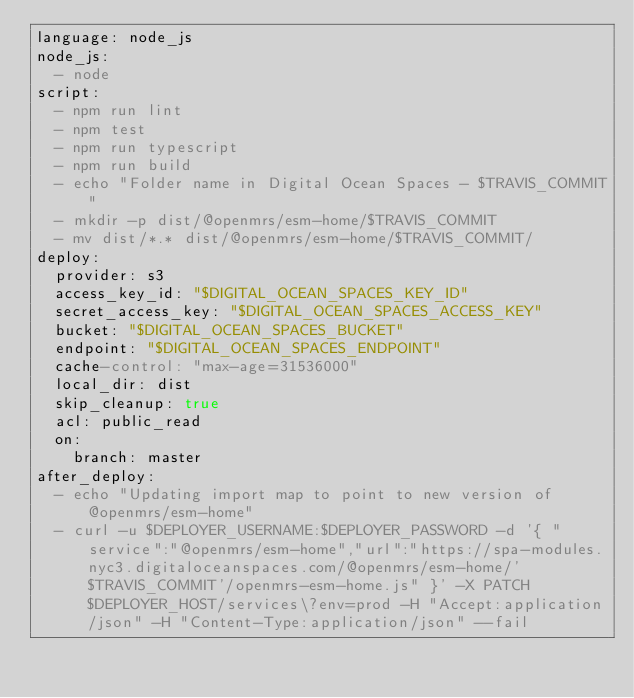<code> <loc_0><loc_0><loc_500><loc_500><_YAML_>language: node_js
node_js:
  - node
script:
  - npm run lint
  - npm test
  - npm run typescript
  - npm run build
  - echo "Folder name in Digital Ocean Spaces - $TRAVIS_COMMIT"
  - mkdir -p dist/@openmrs/esm-home/$TRAVIS_COMMIT
  - mv dist/*.* dist/@openmrs/esm-home/$TRAVIS_COMMIT/
deploy:
  provider: s3
  access_key_id: "$DIGITAL_OCEAN_SPACES_KEY_ID"
  secret_access_key: "$DIGITAL_OCEAN_SPACES_ACCESS_KEY"
  bucket: "$DIGITAL_OCEAN_SPACES_BUCKET"
  endpoint: "$DIGITAL_OCEAN_SPACES_ENDPOINT"
  cache-control: "max-age=31536000"
  local_dir: dist
  skip_cleanup: true
  acl: public_read
  on:
    branch: master
after_deploy:
  - echo "Updating import map to point to new version of @openmrs/esm-home"
  - curl -u $DEPLOYER_USERNAME:$DEPLOYER_PASSWORD -d '{ "service":"@openmrs/esm-home","url":"https://spa-modules.nyc3.digitaloceanspaces.com/@openmrs/esm-home/'$TRAVIS_COMMIT'/openmrs-esm-home.js" }' -X PATCH $DEPLOYER_HOST/services\?env=prod -H "Accept:application/json" -H "Content-Type:application/json" --fail
</code> 